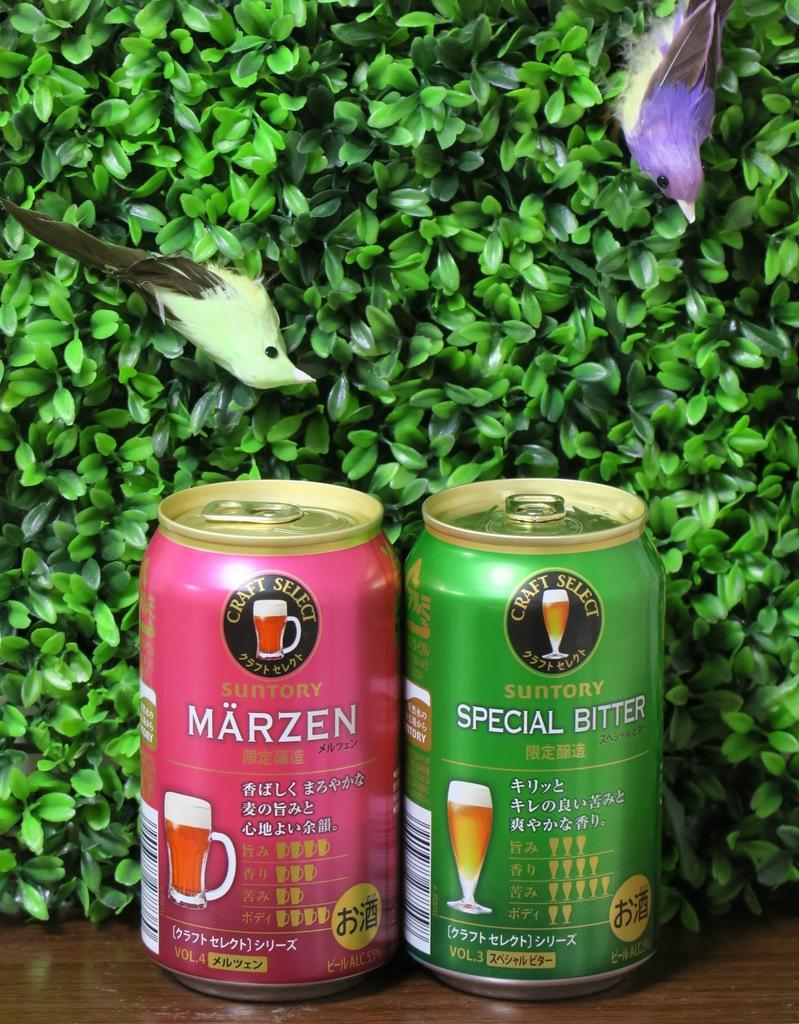Provide a one-sentence caption for the provided image. Two beer cans that say Craft Select are in front of a bush with two fake birds in it. 